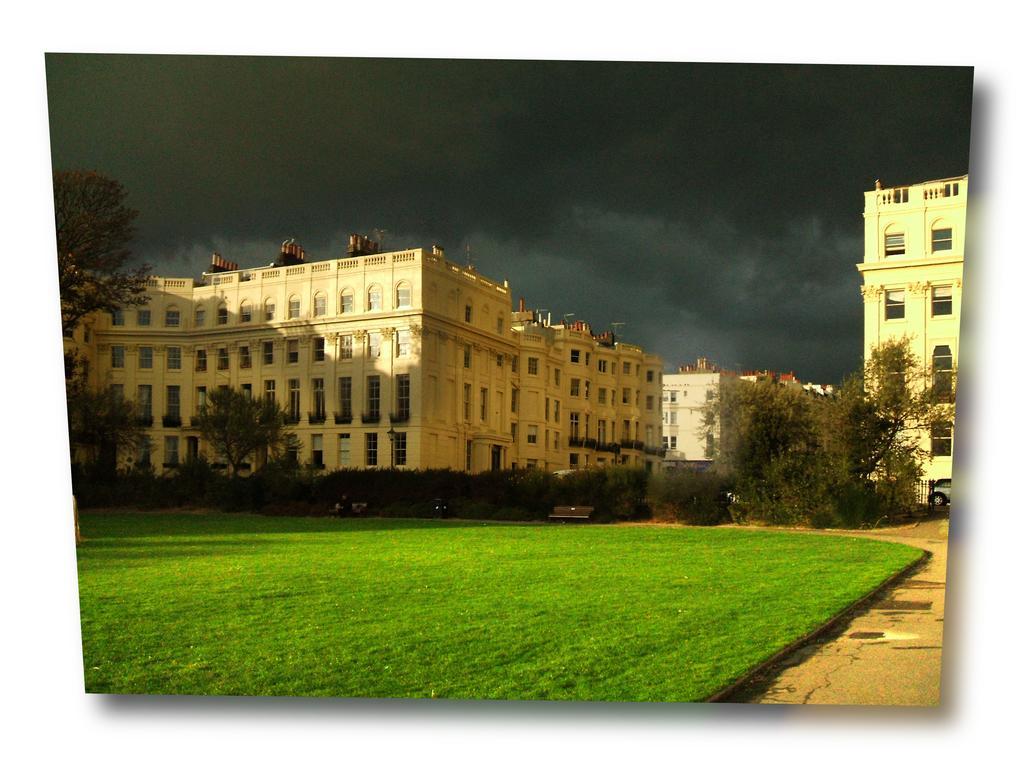How would you summarize this image in a sentence or two? In this image I can see grass, few trees, few buildings, clouds, the sky and number of windows. I can also see a bench over there. 